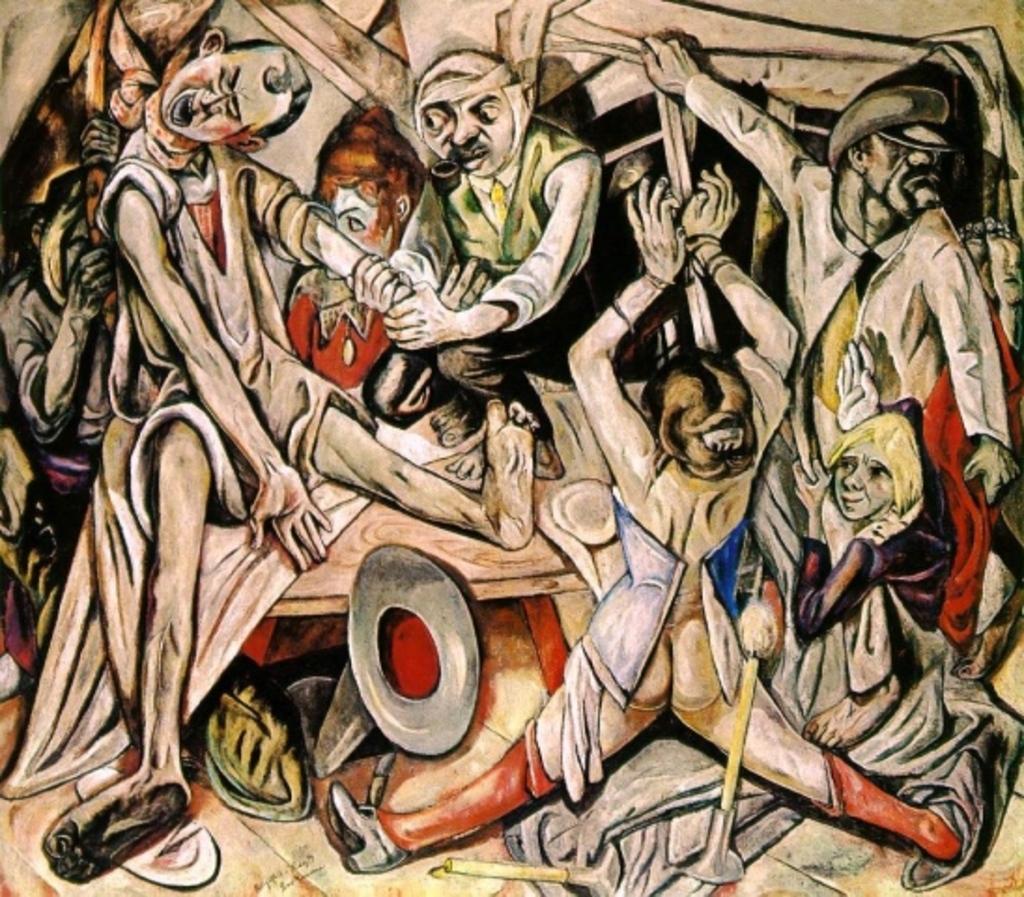In one or two sentences, can you explain what this image depicts? In this picture we can see drawing of people. 